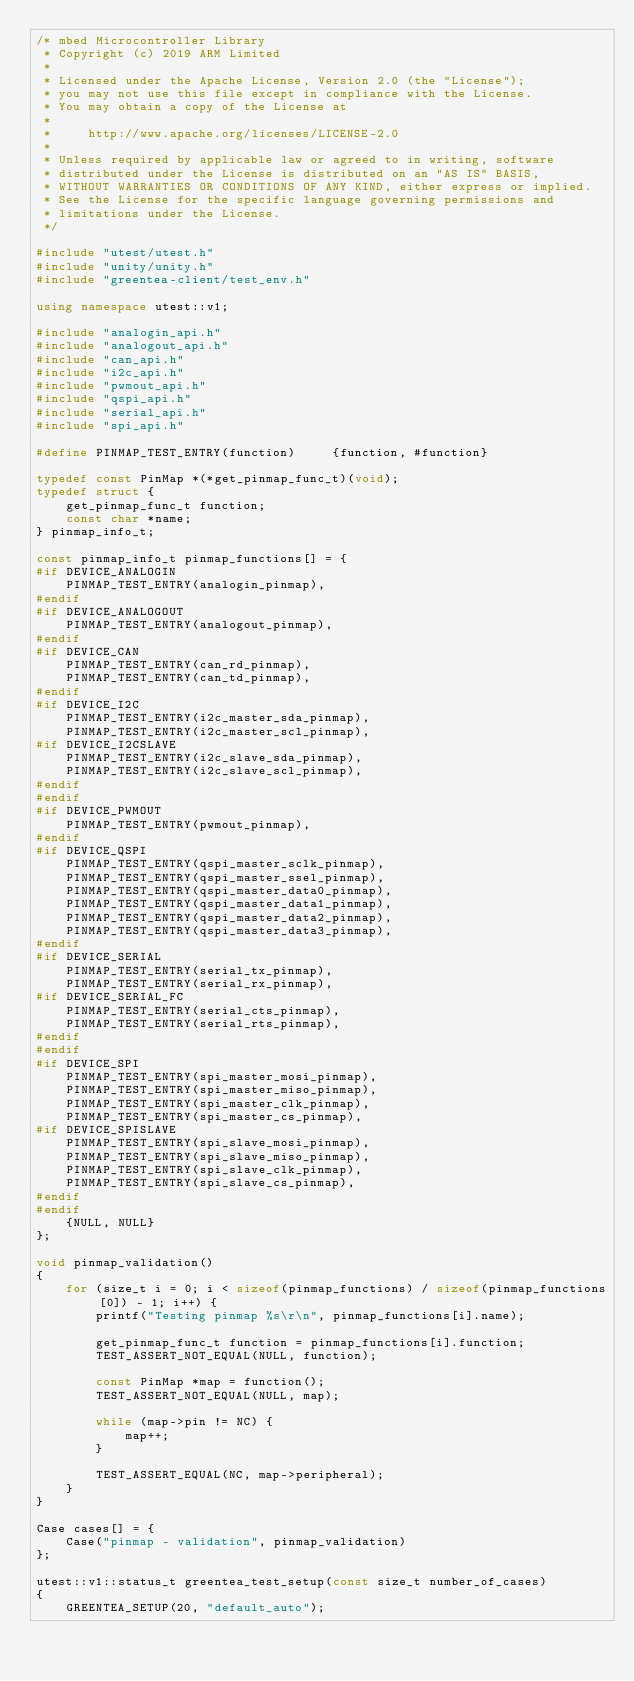<code> <loc_0><loc_0><loc_500><loc_500><_C++_>/* mbed Microcontroller Library
 * Copyright (c) 2019 ARM Limited
 *
 * Licensed under the Apache License, Version 2.0 (the "License");
 * you may not use this file except in compliance with the License.
 * You may obtain a copy of the License at
 *
 *     http://www.apache.org/licenses/LICENSE-2.0
 *
 * Unless required by applicable law or agreed to in writing, software
 * distributed under the License is distributed on an "AS IS" BASIS,
 * WITHOUT WARRANTIES OR CONDITIONS OF ANY KIND, either express or implied.
 * See the License for the specific language governing permissions and
 * limitations under the License.
 */

#include "utest/utest.h"
#include "unity/unity.h"
#include "greentea-client/test_env.h"

using namespace utest::v1;

#include "analogin_api.h"
#include "analogout_api.h"
#include "can_api.h"
#include "i2c_api.h"
#include "pwmout_api.h"
#include "qspi_api.h"
#include "serial_api.h"
#include "spi_api.h"

#define PINMAP_TEST_ENTRY(function)     {function, #function}

typedef const PinMap *(*get_pinmap_func_t)(void);
typedef struct {
    get_pinmap_func_t function;
    const char *name;
} pinmap_info_t;

const pinmap_info_t pinmap_functions[] = {
#if DEVICE_ANALOGIN
    PINMAP_TEST_ENTRY(analogin_pinmap),
#endif
#if DEVICE_ANALOGOUT
    PINMAP_TEST_ENTRY(analogout_pinmap),
#endif
#if DEVICE_CAN
    PINMAP_TEST_ENTRY(can_rd_pinmap),
    PINMAP_TEST_ENTRY(can_td_pinmap),
#endif
#if DEVICE_I2C
    PINMAP_TEST_ENTRY(i2c_master_sda_pinmap),
    PINMAP_TEST_ENTRY(i2c_master_scl_pinmap),
#if DEVICE_I2CSLAVE
    PINMAP_TEST_ENTRY(i2c_slave_sda_pinmap),
    PINMAP_TEST_ENTRY(i2c_slave_scl_pinmap),
#endif
#endif
#if DEVICE_PWMOUT
    PINMAP_TEST_ENTRY(pwmout_pinmap),
#endif
#if DEVICE_QSPI
    PINMAP_TEST_ENTRY(qspi_master_sclk_pinmap),
    PINMAP_TEST_ENTRY(qspi_master_ssel_pinmap),
    PINMAP_TEST_ENTRY(qspi_master_data0_pinmap),
    PINMAP_TEST_ENTRY(qspi_master_data1_pinmap),
    PINMAP_TEST_ENTRY(qspi_master_data2_pinmap),
    PINMAP_TEST_ENTRY(qspi_master_data3_pinmap),
#endif
#if DEVICE_SERIAL
    PINMAP_TEST_ENTRY(serial_tx_pinmap),
    PINMAP_TEST_ENTRY(serial_rx_pinmap),
#if DEVICE_SERIAL_FC
    PINMAP_TEST_ENTRY(serial_cts_pinmap),
    PINMAP_TEST_ENTRY(serial_rts_pinmap),
#endif
#endif
#if DEVICE_SPI
    PINMAP_TEST_ENTRY(spi_master_mosi_pinmap),
    PINMAP_TEST_ENTRY(spi_master_miso_pinmap),
    PINMAP_TEST_ENTRY(spi_master_clk_pinmap),
    PINMAP_TEST_ENTRY(spi_master_cs_pinmap),
#if DEVICE_SPISLAVE
    PINMAP_TEST_ENTRY(spi_slave_mosi_pinmap),
    PINMAP_TEST_ENTRY(spi_slave_miso_pinmap),
    PINMAP_TEST_ENTRY(spi_slave_clk_pinmap),
    PINMAP_TEST_ENTRY(spi_slave_cs_pinmap),
#endif
#endif
    {NULL, NULL}
};

void pinmap_validation()
{
    for (size_t i = 0; i < sizeof(pinmap_functions) / sizeof(pinmap_functions[0]) - 1; i++) {
        printf("Testing pinmap %s\r\n", pinmap_functions[i].name);

        get_pinmap_func_t function = pinmap_functions[i].function;
        TEST_ASSERT_NOT_EQUAL(NULL, function);

        const PinMap *map = function();
        TEST_ASSERT_NOT_EQUAL(NULL, map);

        while (map->pin != NC) {
            map++;
        }

        TEST_ASSERT_EQUAL(NC, map->peripheral);
    }
}

Case cases[] = {
    Case("pinmap - validation", pinmap_validation)
};

utest::v1::status_t greentea_test_setup(const size_t number_of_cases)
{
    GREENTEA_SETUP(20, "default_auto");</code> 